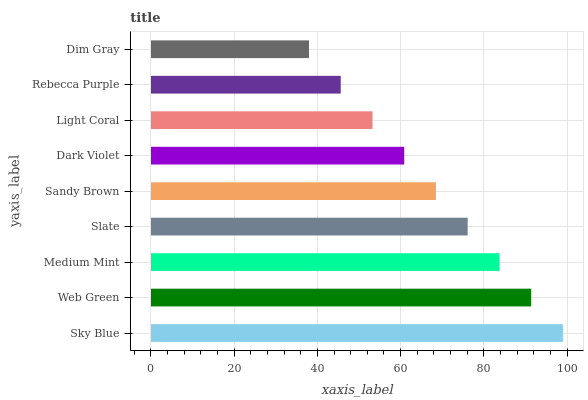Is Dim Gray the minimum?
Answer yes or no. Yes. Is Sky Blue the maximum?
Answer yes or no. Yes. Is Web Green the minimum?
Answer yes or no. No. Is Web Green the maximum?
Answer yes or no. No. Is Sky Blue greater than Web Green?
Answer yes or no. Yes. Is Web Green less than Sky Blue?
Answer yes or no. Yes. Is Web Green greater than Sky Blue?
Answer yes or no. No. Is Sky Blue less than Web Green?
Answer yes or no. No. Is Sandy Brown the high median?
Answer yes or no. Yes. Is Sandy Brown the low median?
Answer yes or no. Yes. Is Dim Gray the high median?
Answer yes or no. No. Is Medium Mint the low median?
Answer yes or no. No. 